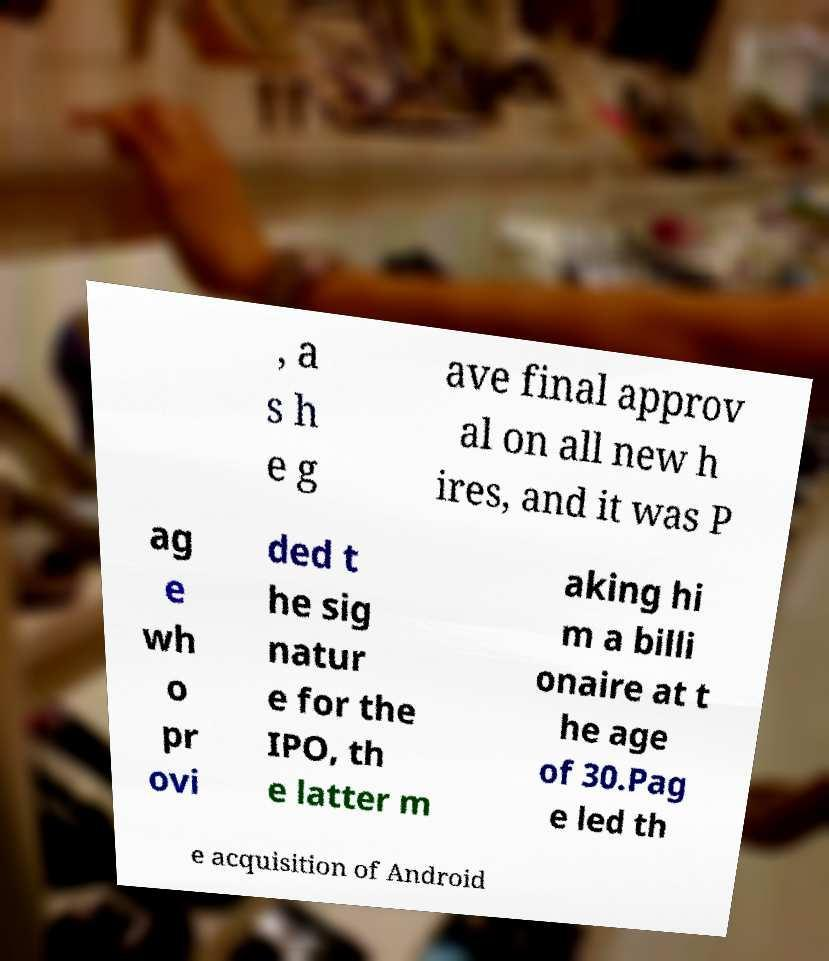Please identify and transcribe the text found in this image. , a s h e g ave final approv al on all new h ires, and it was P ag e wh o pr ovi ded t he sig natur e for the IPO, th e latter m aking hi m a billi onaire at t he age of 30.Pag e led th e acquisition of Android 